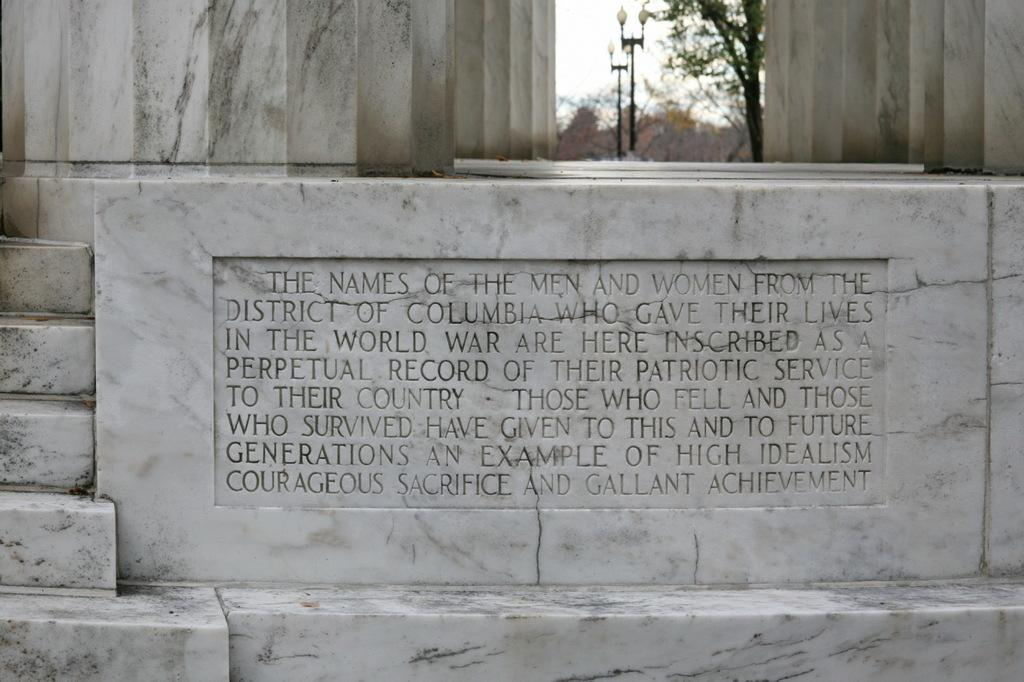What is written or depicted on the marble in the image? There is text on the marble in the image. What can be seen in the background of the image? There are poles and trees in the background of the image. How many birds are perched on the poles in the image? There are no birds visible in the image; only poles and trees can be seen in the background. 